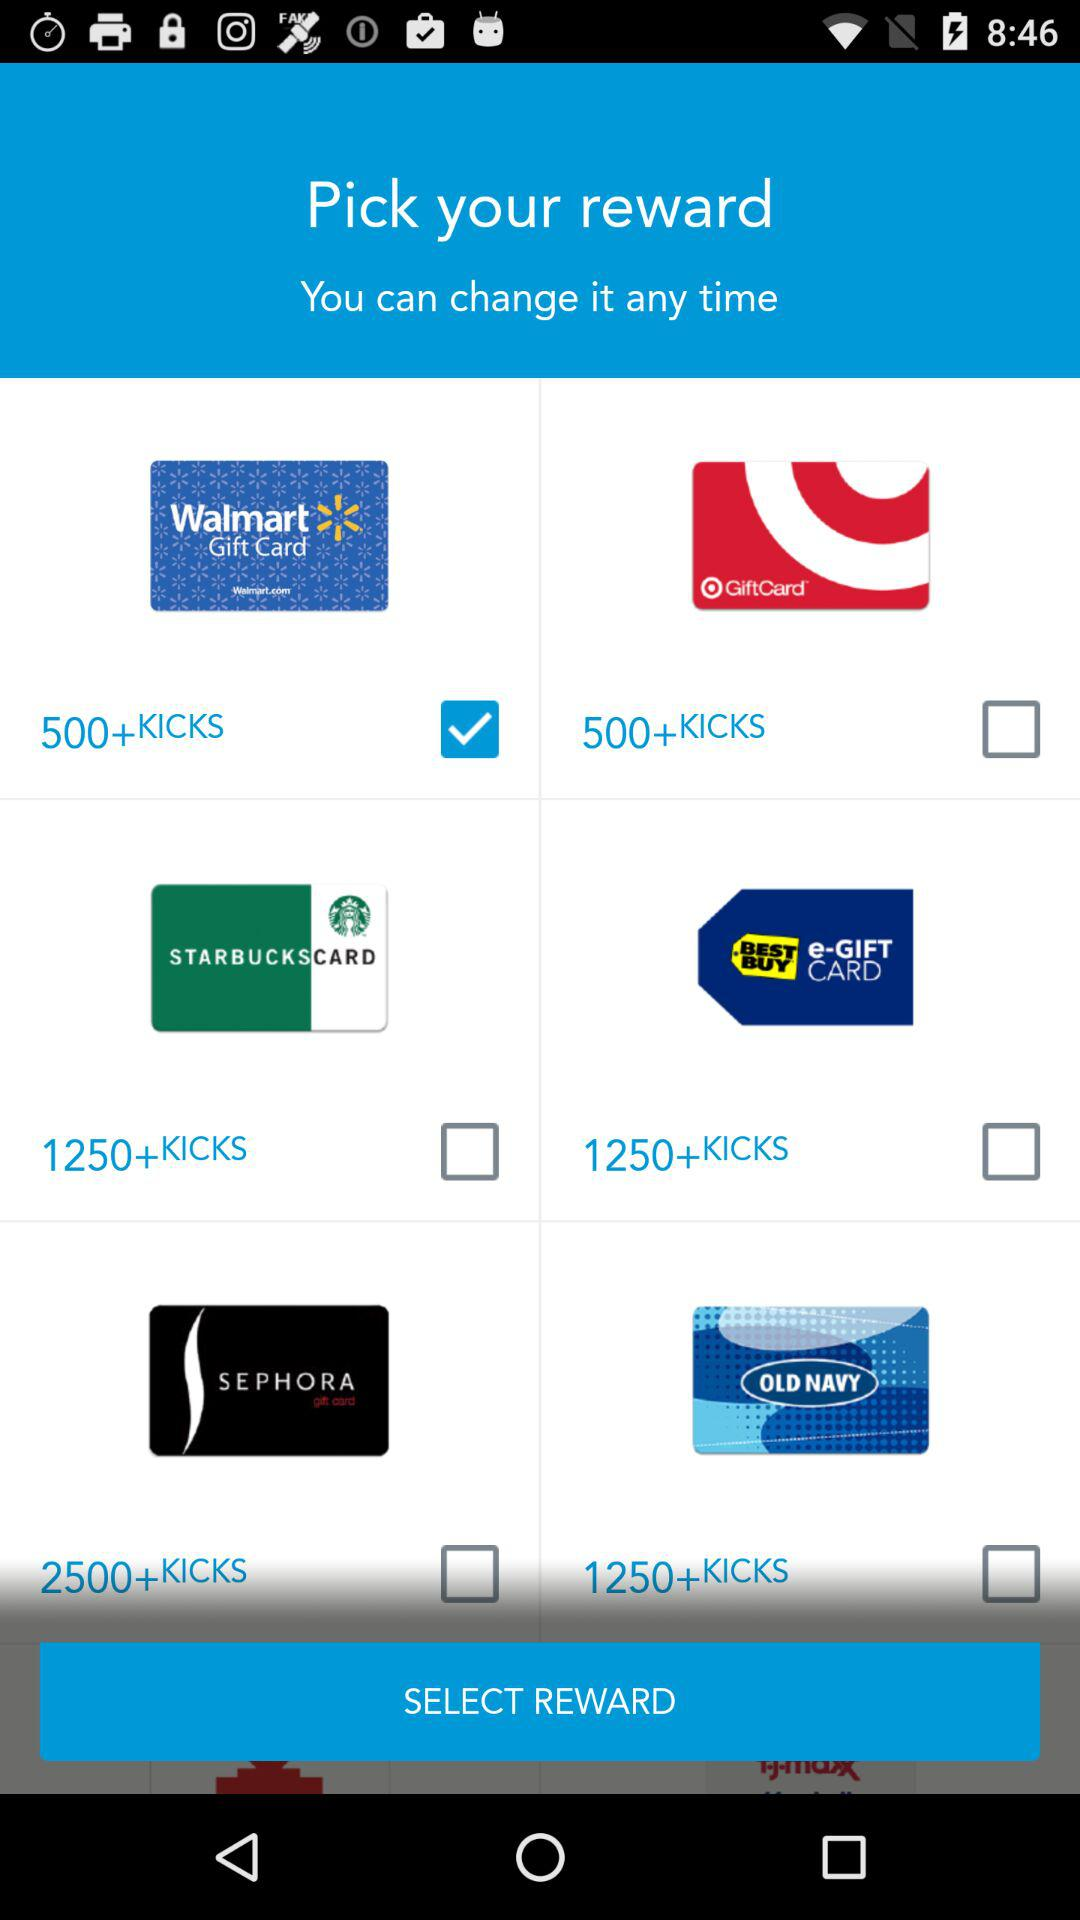How many rewards have a value of 1250+KICKS?
Answer the question using a single word or phrase. 3 